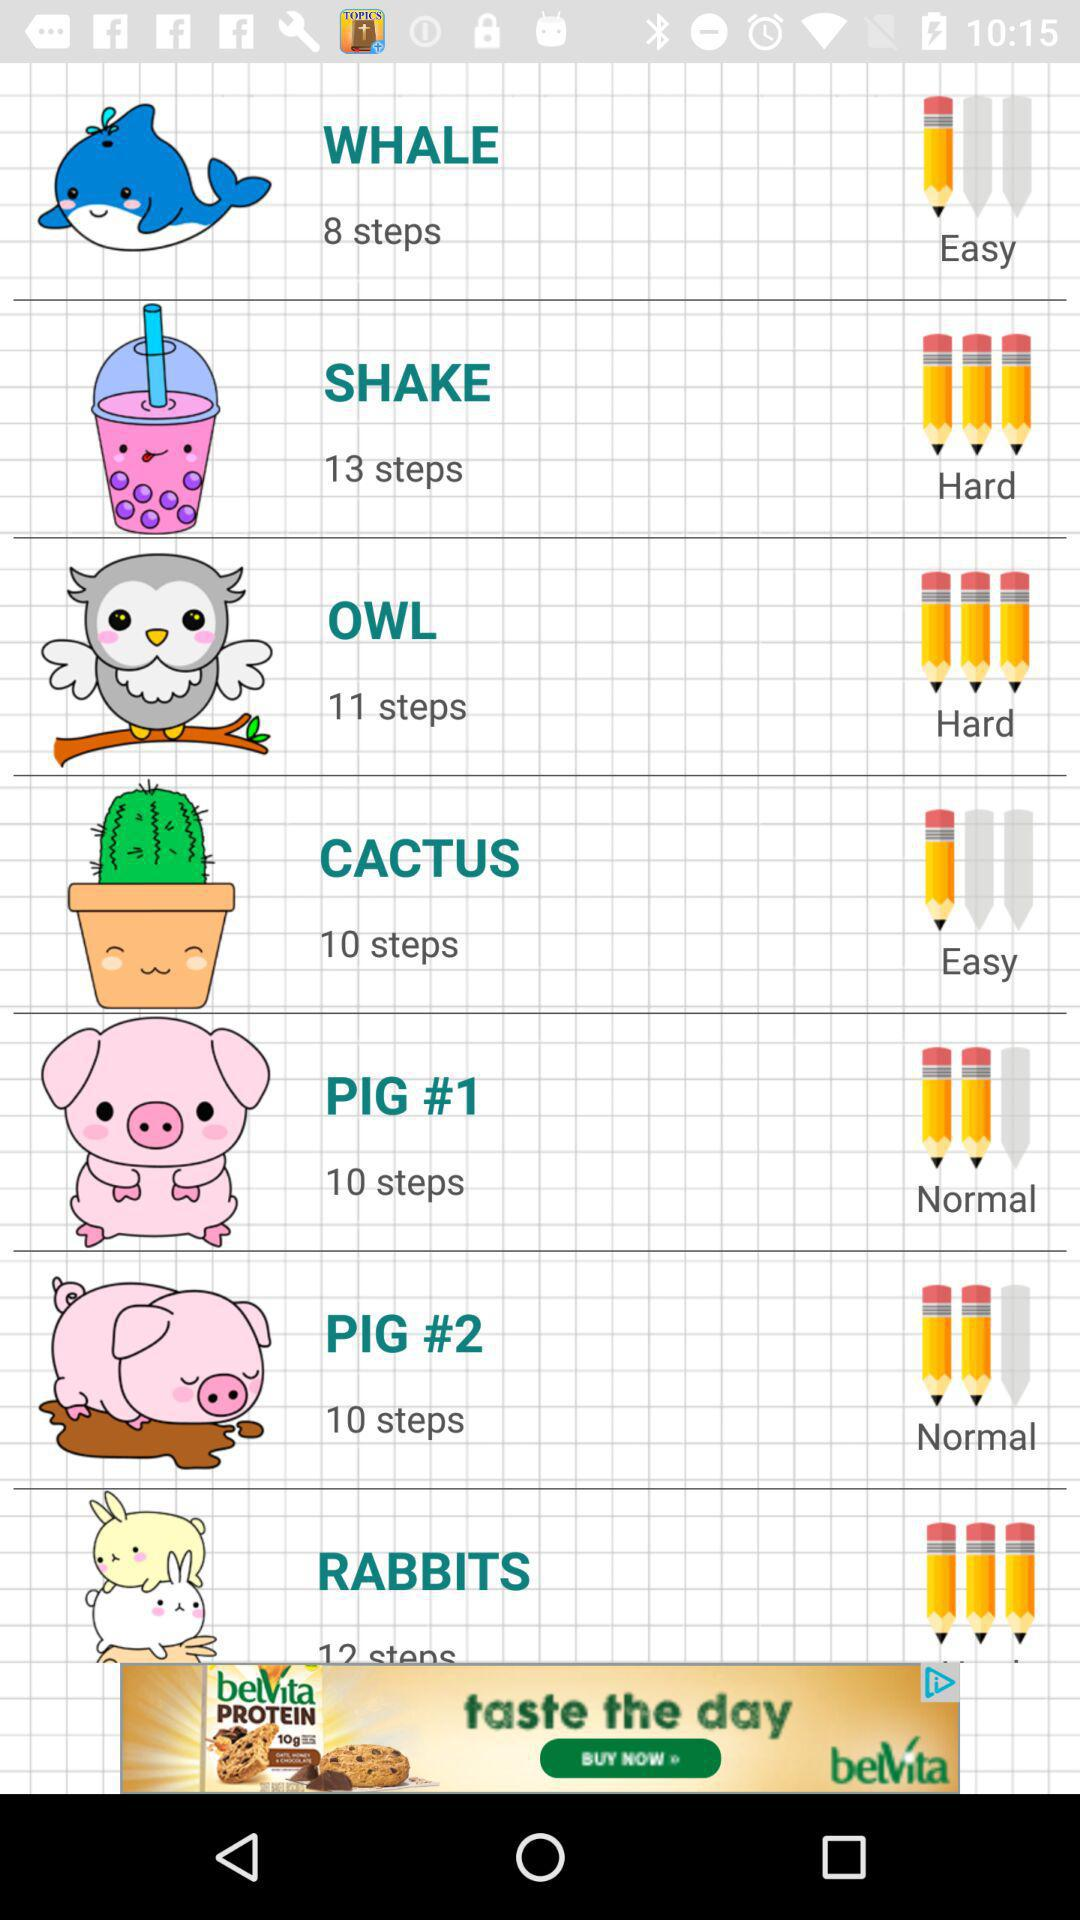How many steps are there in "OWL"? There are 11 steps. 